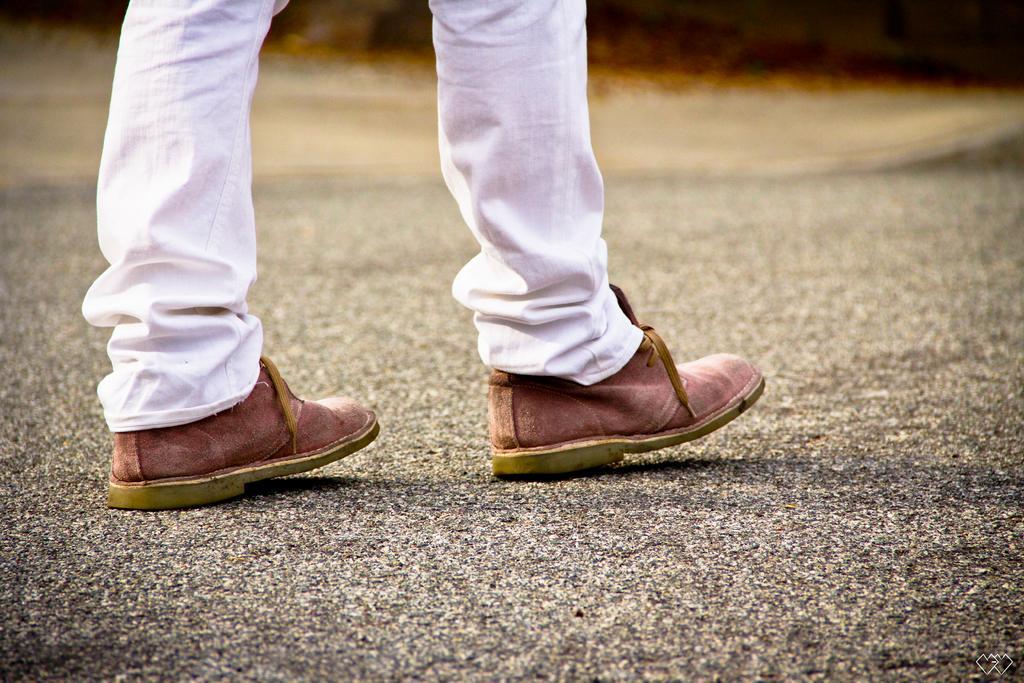Can you describe this image briefly? In the center of the image we can see a person's legs are there. In the background of the image road is there. 